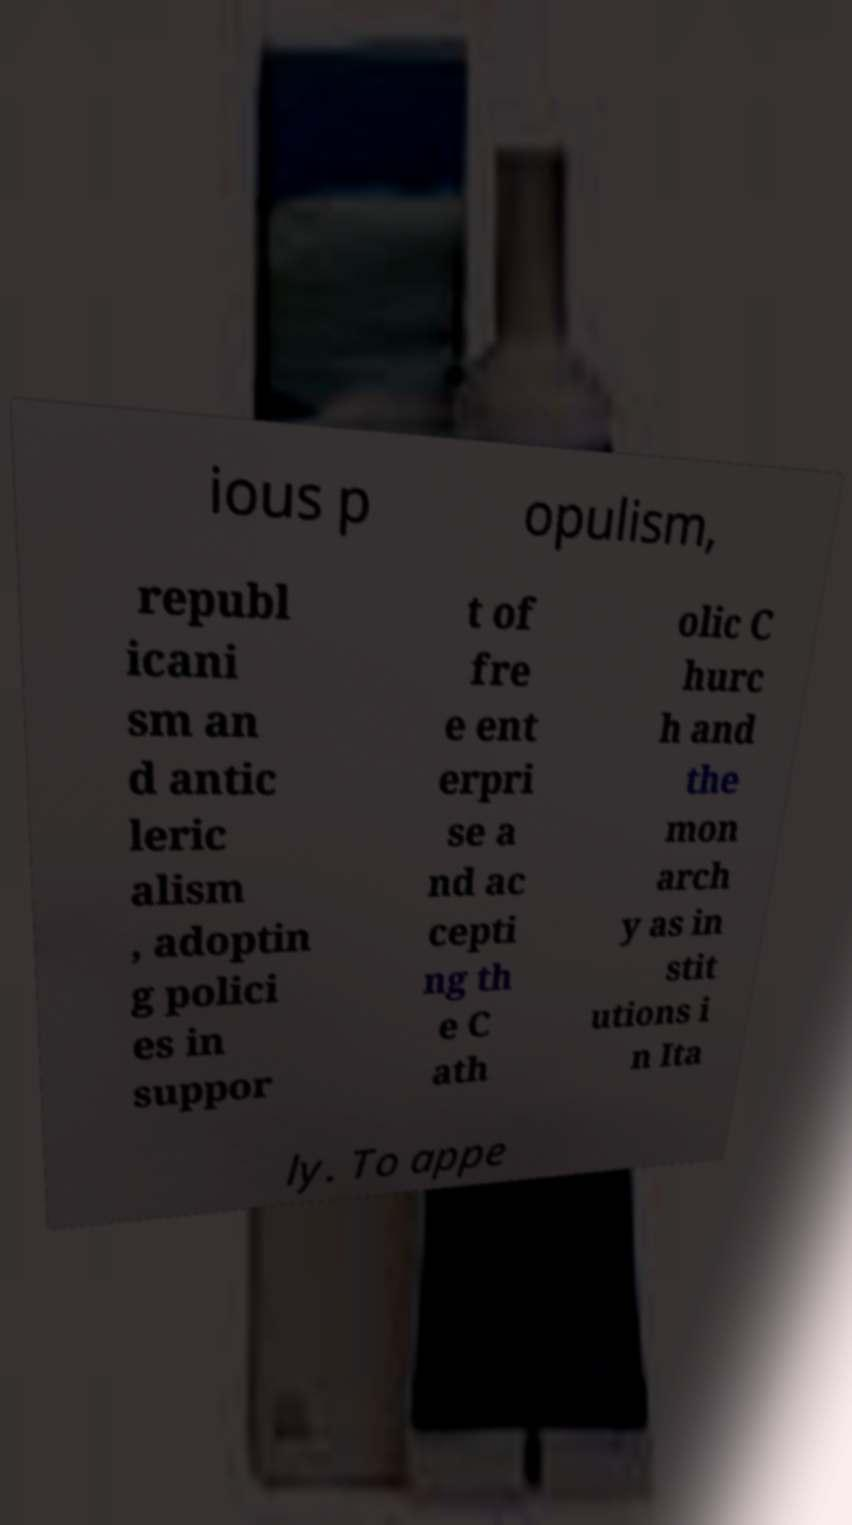Can you read and provide the text displayed in the image?This photo seems to have some interesting text. Can you extract and type it out for me? ious p opulism, republ icani sm an d antic leric alism , adoptin g polici es in suppor t of fre e ent erpri se a nd ac cepti ng th e C ath olic C hurc h and the mon arch y as in stit utions i n Ita ly. To appe 